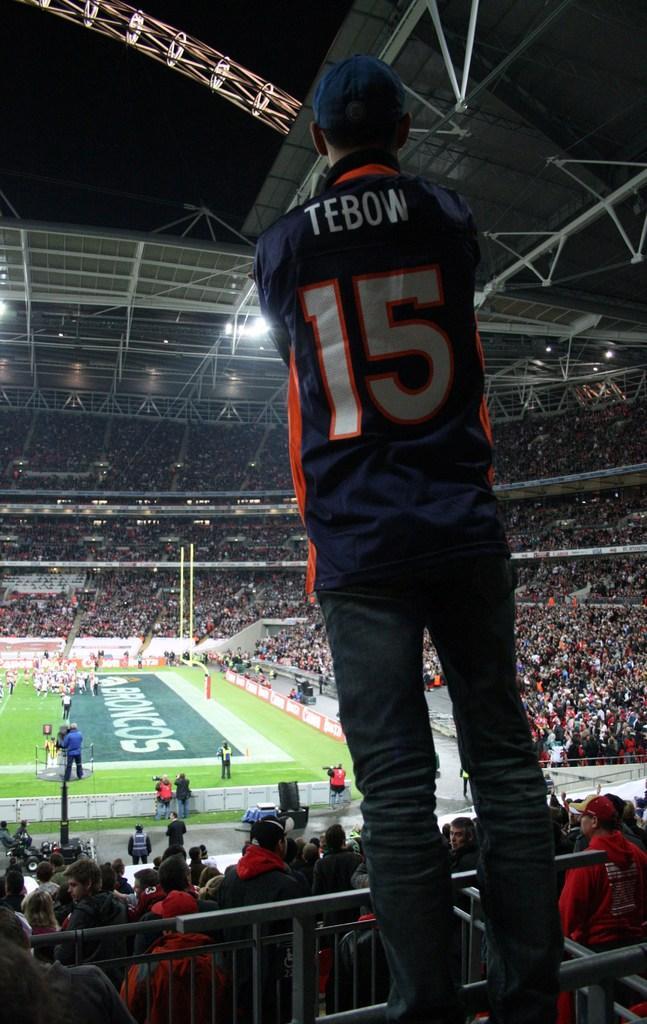Describe this image in one or two sentences. This is a picture of a stadium, where there is a person standing , there are iron rods, group of people, there are lights, lighting truss and in the background there is sky. 